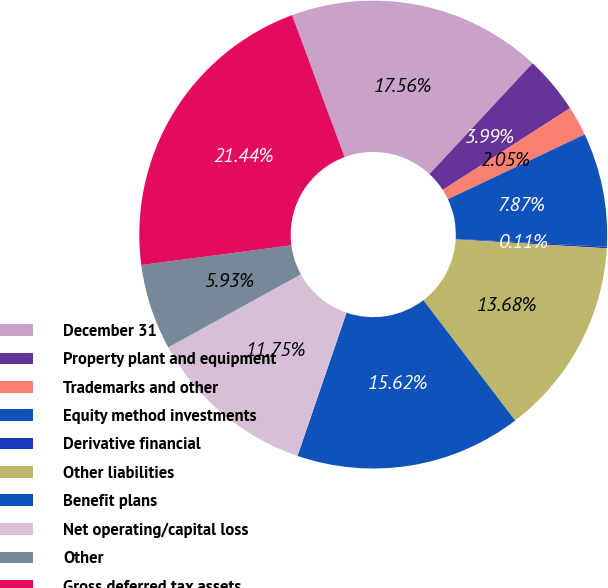Convert chart to OTSL. <chart><loc_0><loc_0><loc_500><loc_500><pie_chart><fcel>December 31<fcel>Property plant and equipment<fcel>Trademarks and other<fcel>Equity method investments<fcel>Derivative financial<fcel>Other liabilities<fcel>Benefit plans<fcel>Net operating/capital loss<fcel>Other<fcel>Gross deferred tax assets<nl><fcel>17.57%<fcel>3.99%<fcel>2.05%<fcel>7.87%<fcel>0.11%<fcel>13.69%<fcel>15.63%<fcel>11.75%<fcel>5.93%<fcel>21.45%<nl></chart> 